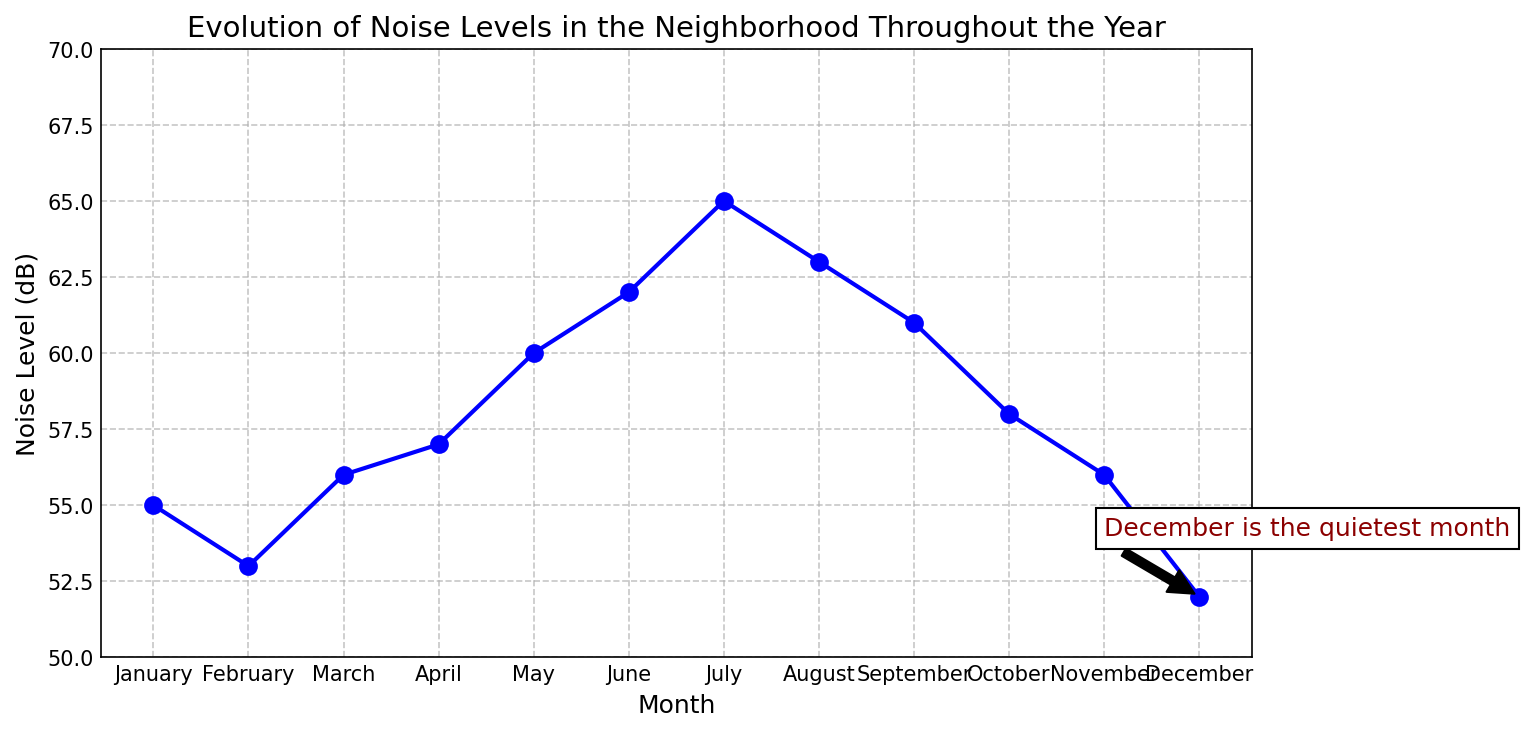How does the noise level in July compare to that in December? To find this, observe the noise level values for July and December on the y-axis. July has a noise level of 65 dB while December has 52 dB. Thus, July is noisier.
Answer: July is noisier Which month has the lowest noise level and what is it? The annotation indicates that December is the quietest month. By looking at the data point, December’s noise level is 52 dB.
Answer: December, 52 dB Which month has the highest noise level and what is it? By visually inspecting the graph, July's data point reaches the highest position on the y-axis, with a noise level of 65 dB.
Answer: July, 65 dB What is the difference in noise levels between the loudest and quietest months? The loudest month is July with 65 dB, and the quietest is December with 52 dB. So, the difference is 65 - 52 = 13 dB.
Answer: 13 dB Is there an increasing trend in noise levels from January to July? By following the line from January to July, the noise levels increase from 55 dB in January to 65 dB in July, showing an upward trend.
Answer: Yes How does the noise level change from May to June? The noise level increases from May to June; May has 60 dB, and June has 62 dB. Thus, it increases by 2 dB.
Answer: Increases by 2 dB How many months have noise levels above 60 dB? By counting the months where the noise level is above 60 dB, we get June, July, August, and September, totaling 4 months.
Answer: 4 months What is the average noise level from January to December? Sum the noise levels from January to December (55 + 53 + 56 + 57 + 60 + 62 + 65 + 63 + 61 + 58 + 56 + 52) and divide by 12. The total is 698, so the average is 698 ÷ 12 ≈ 58.17 dB.
Answer: 58.17 dB Are October and November noise levels the same? By looking at the data points, October has 58 dB and November has 56 dB, so they are not the same.
Answer: No 